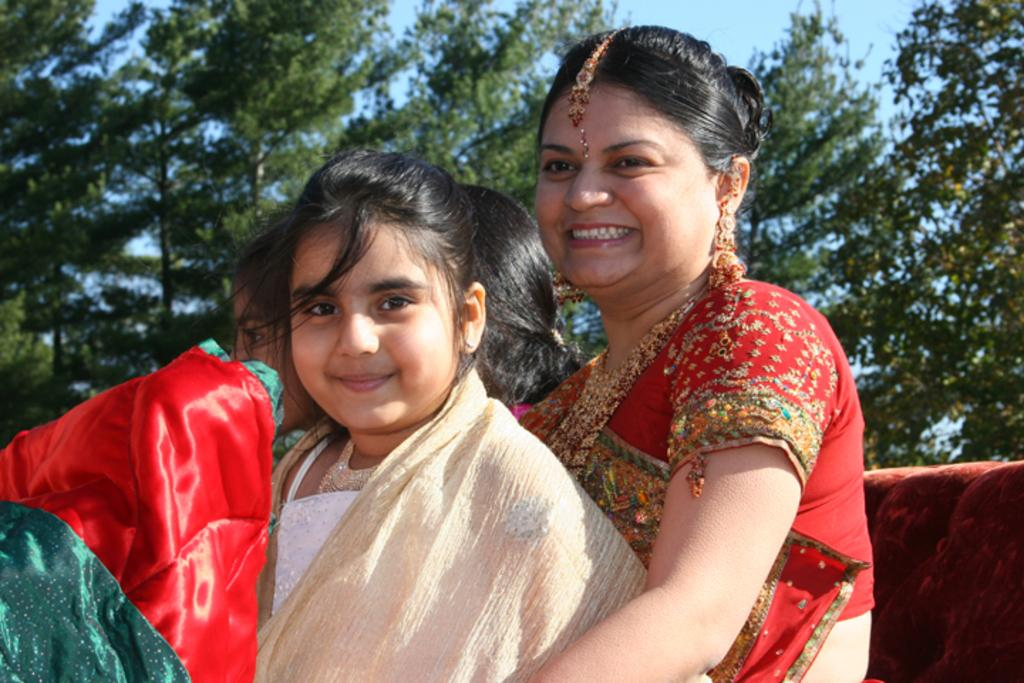How many people are in the image? There are three persons in the image. Can you describe the gender of the people in the image? One of the persons is a woman, and the other two are girls. What is the woman wearing in the image? The woman is wearing a red color saree. What can be seen in the background of the image? There are trees in the background of the image. What type of game is being played in the image? There is no game being played in the image; it features three people, one of whom is a woman wearing a red color saree, and two girls, with trees in the background. Can you tell me how many airports are visible in the image? There are no airports present in the image. 